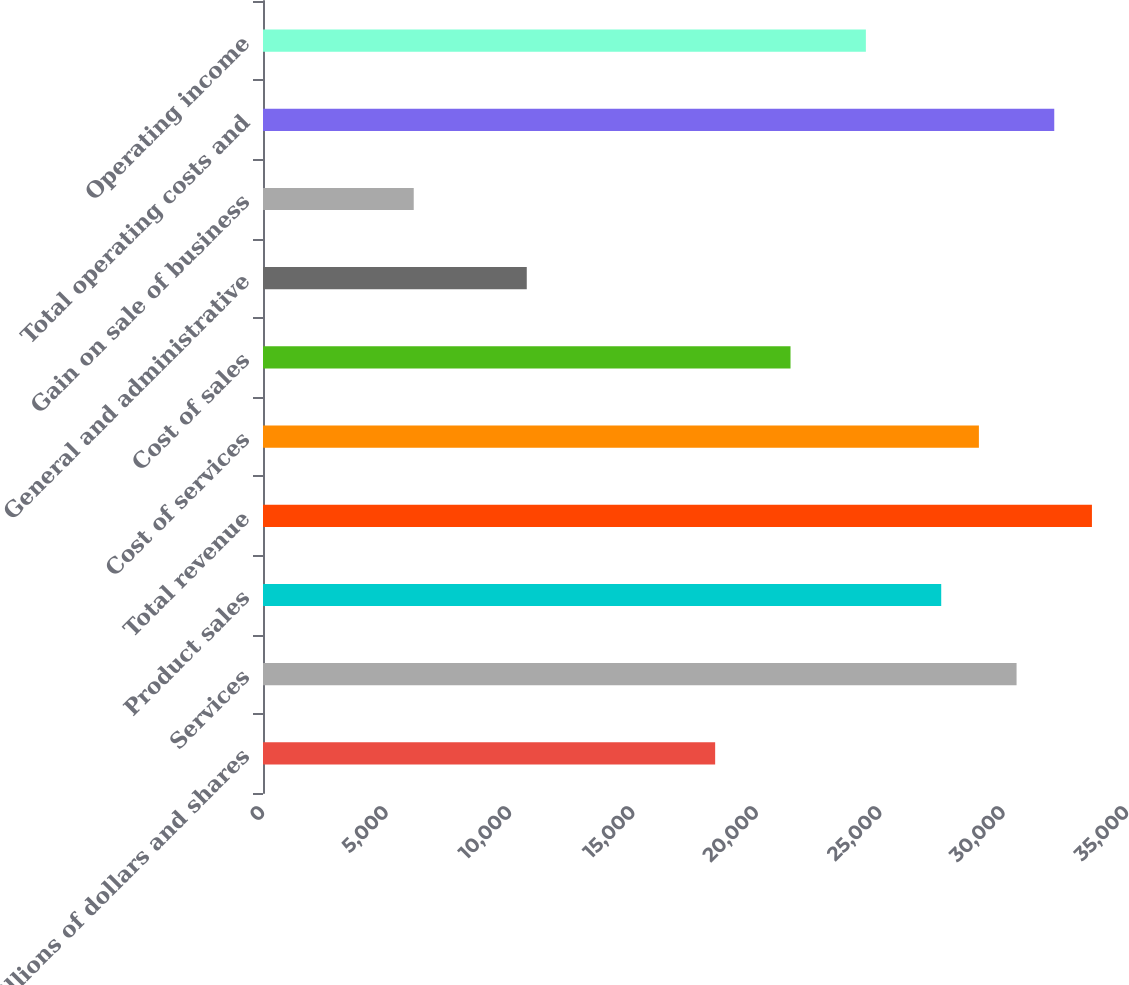Convert chart to OTSL. <chart><loc_0><loc_0><loc_500><loc_500><bar_chart><fcel>Millions of dollars and shares<fcel>Services<fcel>Product sales<fcel>Total revenue<fcel>Cost of services<fcel>Cost of sales<fcel>General and administrative<fcel>Gain on sale of business<fcel>Total operating costs and<fcel>Operating income<nl><fcel>18316.5<fcel>30526.9<fcel>27474.3<fcel>33579.4<fcel>29000.6<fcel>21369.1<fcel>10685.1<fcel>6106.23<fcel>32053.2<fcel>24421.7<nl></chart> 